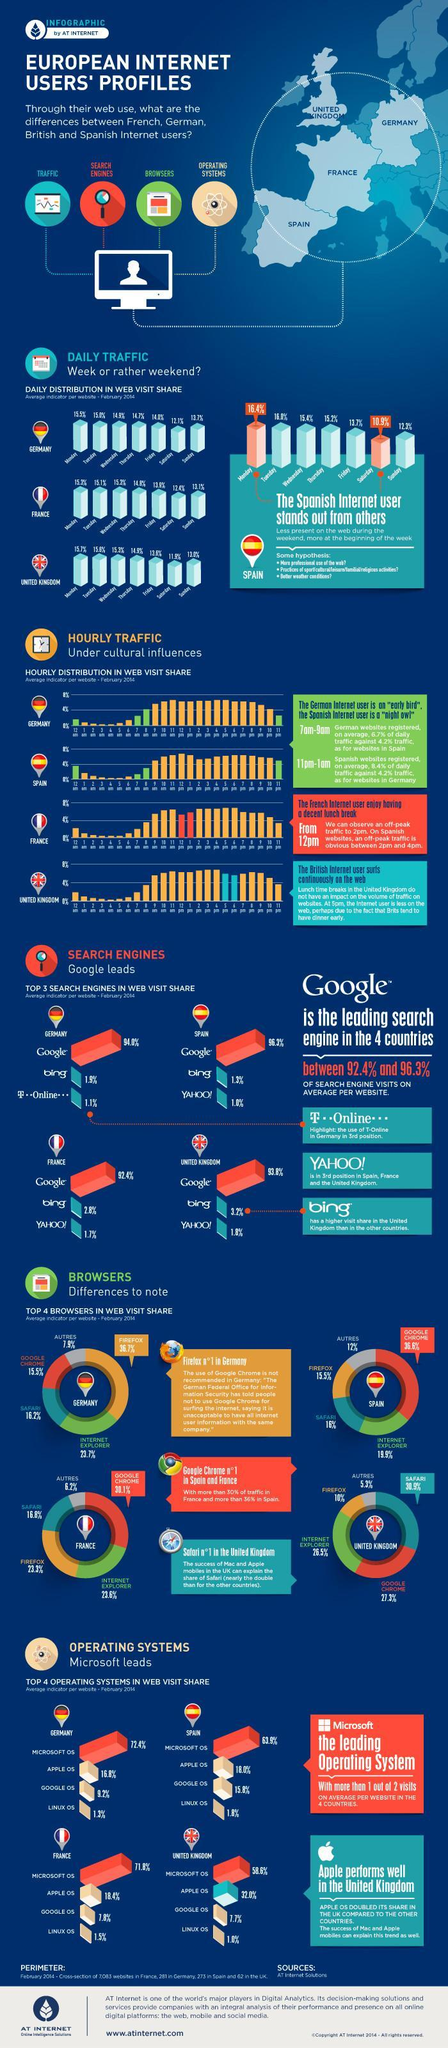Which total percentage of users visiting websites on Monday ?
Answer the question with a short phrase. 62.9% Which country has an off peak pattern from 12 pm to 2 pm, Germany, Spain, or France ? France What is the average percentage of Google' s web visit share in all four countries? 94.125% What is the total percentage of Linux OS users? 5.6% Which country has the lowest percentage of website visitors on Sunday, France, Germany, or United Kingdom? United Kingdom What is the lowest percentage recorded for web visit share on Fridays? United Kingdom Calculate the difference in the total percentage of web visits in Germany using Autres, and Safari from the total percentage of web visits in France using Autres, and Safari? 1.1% What is the highest percentage share of web visit on Wednesday? 15.4% Which is the most popular browser in Spain and France, Firefox, Google Chrome, or Safari ? Google Chrome Which search engine has the second highest total in web visit share in all four countries? Bing 